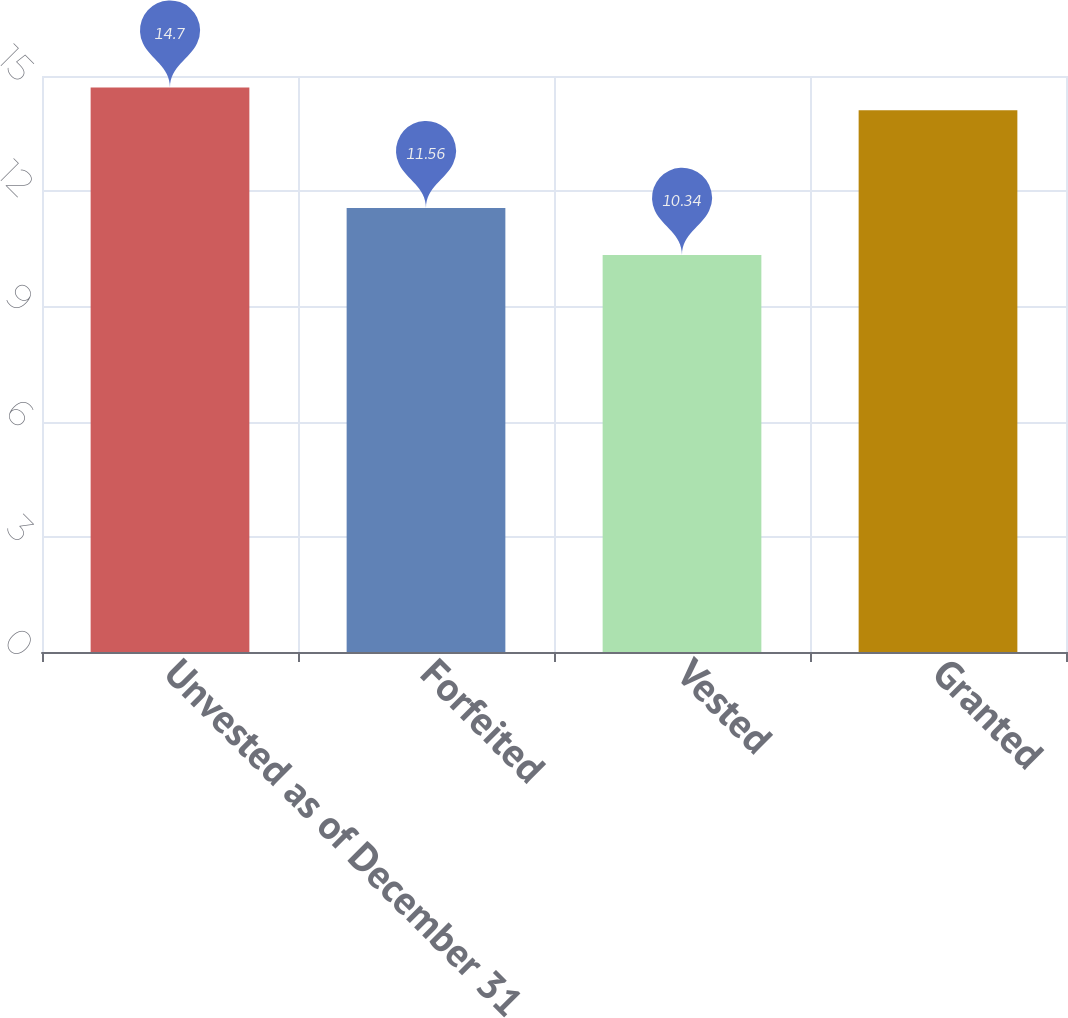Convert chart. <chart><loc_0><loc_0><loc_500><loc_500><bar_chart><fcel>Unvested as of December 31<fcel>Forfeited<fcel>Vested<fcel>Granted<nl><fcel>14.7<fcel>11.56<fcel>10.34<fcel>14.11<nl></chart> 